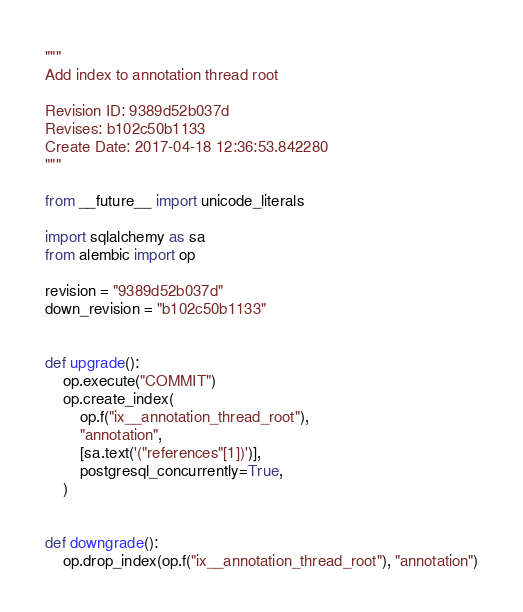<code> <loc_0><loc_0><loc_500><loc_500><_Python_>"""
Add index to annotation thread root

Revision ID: 9389d52b037d
Revises: b102c50b1133
Create Date: 2017-04-18 12:36:53.842280
"""

from __future__ import unicode_literals

import sqlalchemy as sa
from alembic import op

revision = "9389d52b037d"
down_revision = "b102c50b1133"


def upgrade():
    op.execute("COMMIT")
    op.create_index(
        op.f("ix__annotation_thread_root"),
        "annotation",
        [sa.text('("references"[1])')],
        postgresql_concurrently=True,
    )


def downgrade():
    op.drop_index(op.f("ix__annotation_thread_root"), "annotation")
</code> 